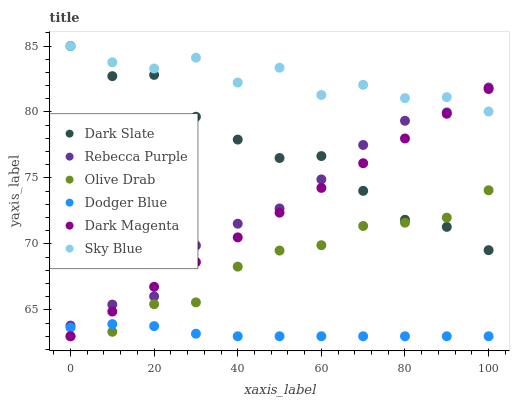Does Dodger Blue have the minimum area under the curve?
Answer yes or no. Yes. Does Sky Blue have the maximum area under the curve?
Answer yes or no. Yes. Does Dark Slate have the minimum area under the curve?
Answer yes or no. No. Does Dark Slate have the maximum area under the curve?
Answer yes or no. No. Is Dark Magenta the smoothest?
Answer yes or no. Yes. Is Sky Blue the roughest?
Answer yes or no. Yes. Is Dark Slate the smoothest?
Answer yes or no. No. Is Dark Slate the roughest?
Answer yes or no. No. Does Dark Magenta have the lowest value?
Answer yes or no. Yes. Does Dark Slate have the lowest value?
Answer yes or no. No. Does Sky Blue have the highest value?
Answer yes or no. Yes. Does Dodger Blue have the highest value?
Answer yes or no. No. Is Olive Drab less than Sky Blue?
Answer yes or no. Yes. Is Rebecca Purple greater than Olive Drab?
Answer yes or no. Yes. Does Rebecca Purple intersect Sky Blue?
Answer yes or no. Yes. Is Rebecca Purple less than Sky Blue?
Answer yes or no. No. Is Rebecca Purple greater than Sky Blue?
Answer yes or no. No. Does Olive Drab intersect Sky Blue?
Answer yes or no. No. 